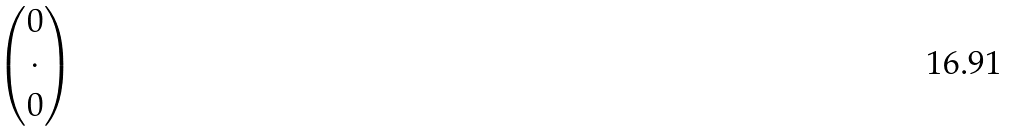<formula> <loc_0><loc_0><loc_500><loc_500>\begin{pmatrix} 0 \\ \cdot \\ 0 \end{pmatrix}</formula> 